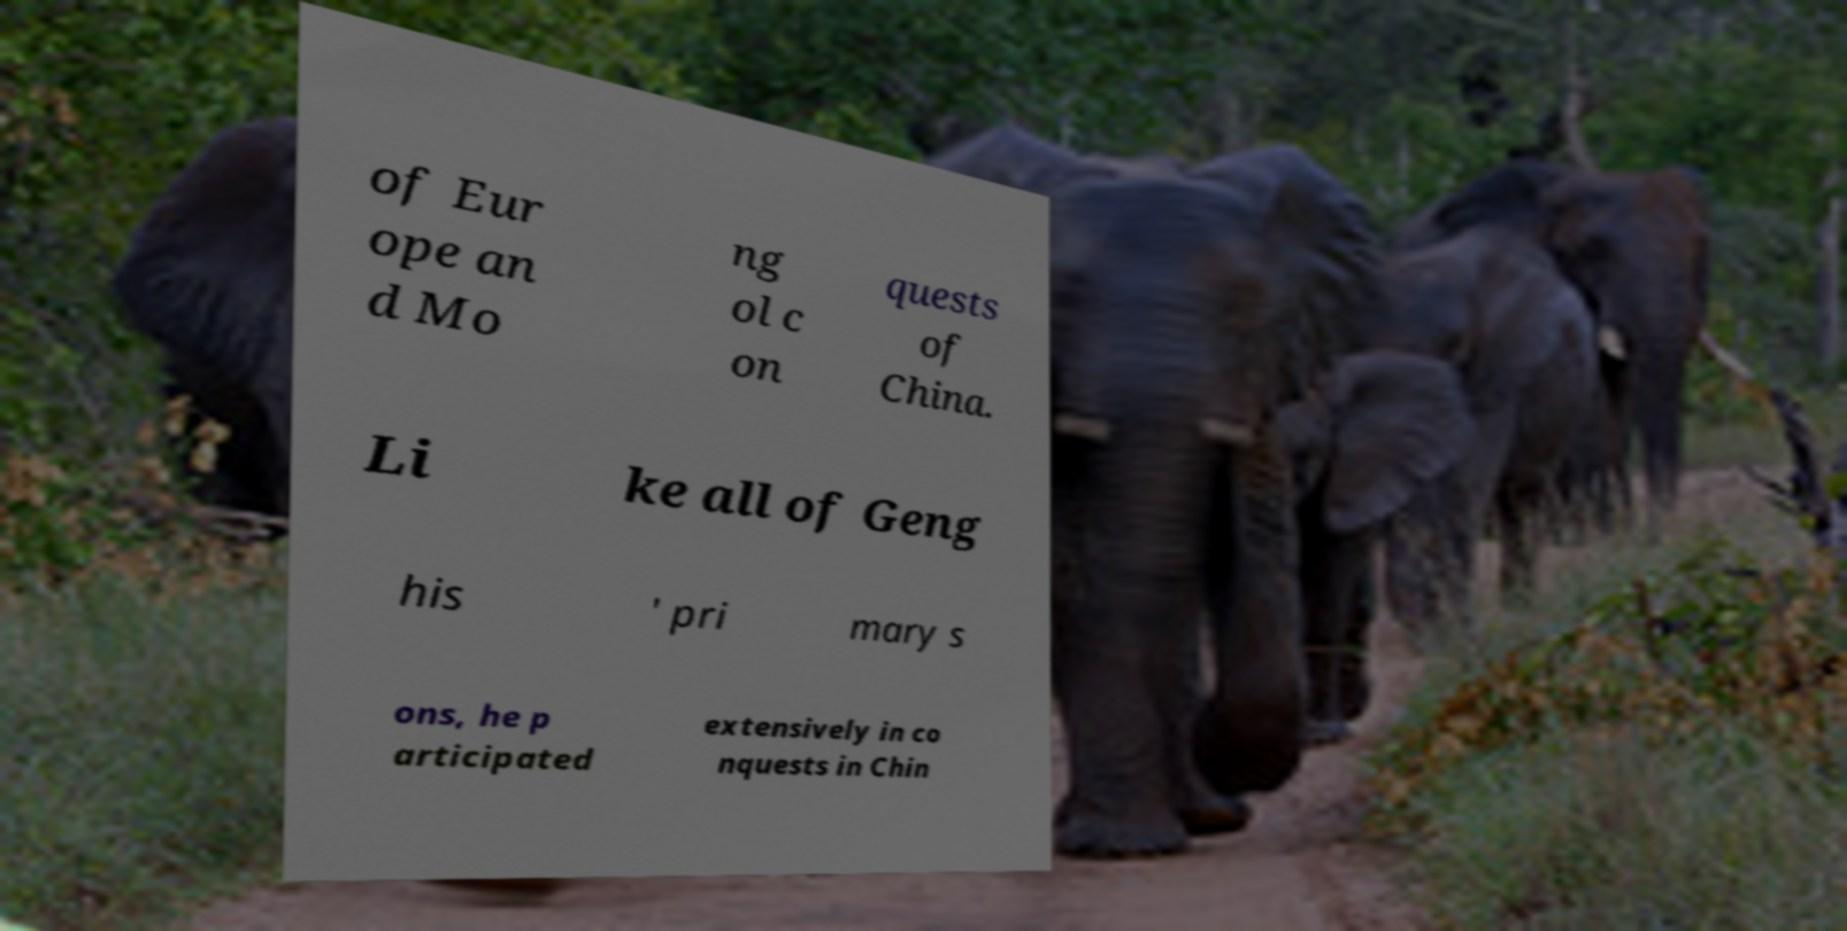Could you assist in decoding the text presented in this image and type it out clearly? of Eur ope an d Mo ng ol c on quests of China. Li ke all of Geng his ' pri mary s ons, he p articipated extensively in co nquests in Chin 